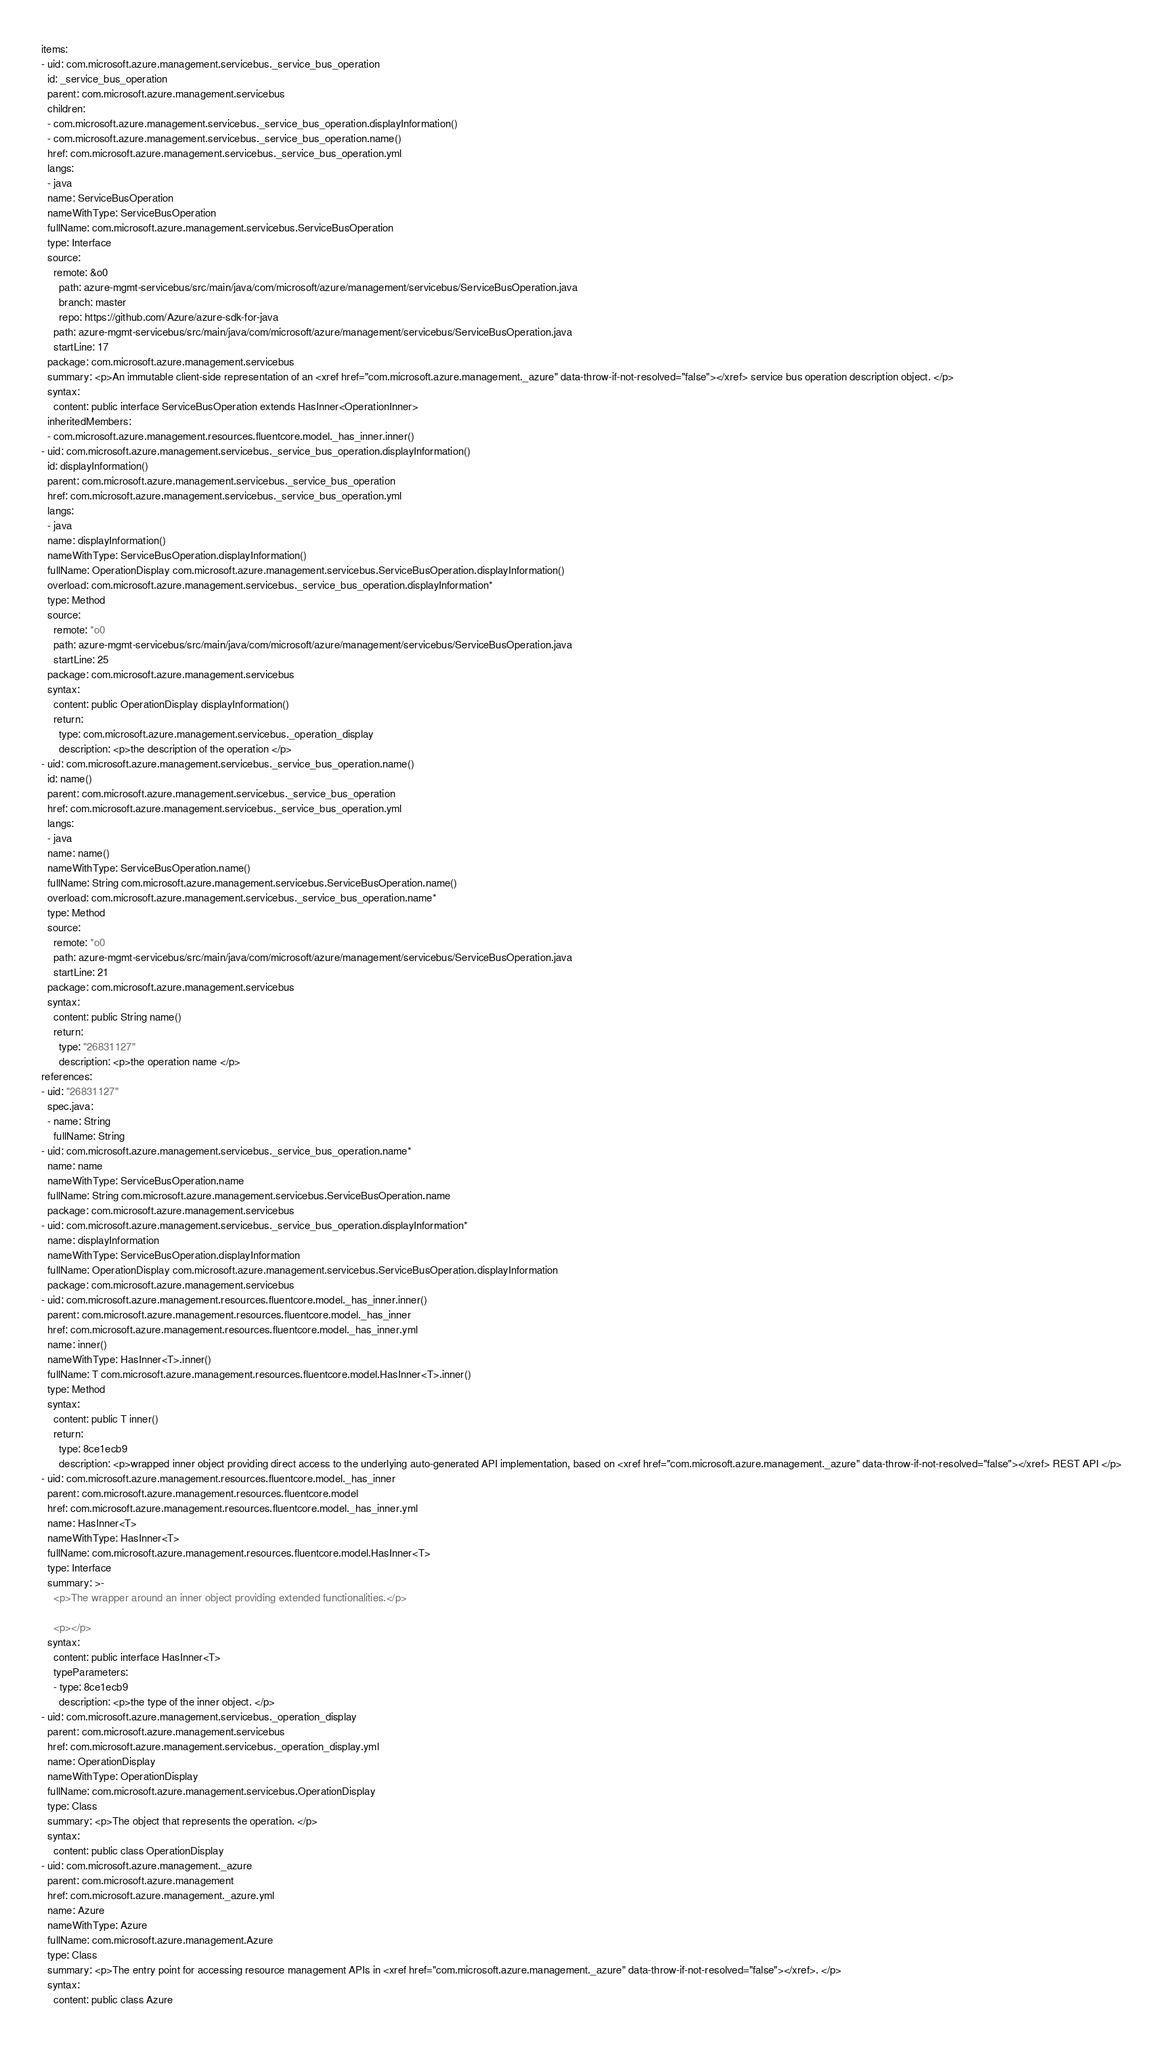Convert code to text. <code><loc_0><loc_0><loc_500><loc_500><_YAML_>items:
- uid: com.microsoft.azure.management.servicebus._service_bus_operation
  id: _service_bus_operation
  parent: com.microsoft.azure.management.servicebus
  children:
  - com.microsoft.azure.management.servicebus._service_bus_operation.displayInformation()
  - com.microsoft.azure.management.servicebus._service_bus_operation.name()
  href: com.microsoft.azure.management.servicebus._service_bus_operation.yml
  langs:
  - java
  name: ServiceBusOperation
  nameWithType: ServiceBusOperation
  fullName: com.microsoft.azure.management.servicebus.ServiceBusOperation
  type: Interface
  source:
    remote: &o0
      path: azure-mgmt-servicebus/src/main/java/com/microsoft/azure/management/servicebus/ServiceBusOperation.java
      branch: master
      repo: https://github.com/Azure/azure-sdk-for-java
    path: azure-mgmt-servicebus/src/main/java/com/microsoft/azure/management/servicebus/ServiceBusOperation.java
    startLine: 17
  package: com.microsoft.azure.management.servicebus
  summary: <p>An immutable client-side representation of an <xref href="com.microsoft.azure.management._azure" data-throw-if-not-resolved="false"></xref> service bus operation description object. </p>
  syntax:
    content: public interface ServiceBusOperation extends HasInner<OperationInner>
  inheritedMembers:
  - com.microsoft.azure.management.resources.fluentcore.model._has_inner.inner()
- uid: com.microsoft.azure.management.servicebus._service_bus_operation.displayInformation()
  id: displayInformation()
  parent: com.microsoft.azure.management.servicebus._service_bus_operation
  href: com.microsoft.azure.management.servicebus._service_bus_operation.yml
  langs:
  - java
  name: displayInformation()
  nameWithType: ServiceBusOperation.displayInformation()
  fullName: OperationDisplay com.microsoft.azure.management.servicebus.ServiceBusOperation.displayInformation()
  overload: com.microsoft.azure.management.servicebus._service_bus_operation.displayInformation*
  type: Method
  source:
    remote: *o0
    path: azure-mgmt-servicebus/src/main/java/com/microsoft/azure/management/servicebus/ServiceBusOperation.java
    startLine: 25
  package: com.microsoft.azure.management.servicebus
  syntax:
    content: public OperationDisplay displayInformation()
    return:
      type: com.microsoft.azure.management.servicebus._operation_display
      description: <p>the description of the operation </p>
- uid: com.microsoft.azure.management.servicebus._service_bus_operation.name()
  id: name()
  parent: com.microsoft.azure.management.servicebus._service_bus_operation
  href: com.microsoft.azure.management.servicebus._service_bus_operation.yml
  langs:
  - java
  name: name()
  nameWithType: ServiceBusOperation.name()
  fullName: String com.microsoft.azure.management.servicebus.ServiceBusOperation.name()
  overload: com.microsoft.azure.management.servicebus._service_bus_operation.name*
  type: Method
  source:
    remote: *o0
    path: azure-mgmt-servicebus/src/main/java/com/microsoft/azure/management/servicebus/ServiceBusOperation.java
    startLine: 21
  package: com.microsoft.azure.management.servicebus
  syntax:
    content: public String name()
    return:
      type: "26831127"
      description: <p>the operation name </p>
references:
- uid: "26831127"
  spec.java:
  - name: String
    fullName: String
- uid: com.microsoft.azure.management.servicebus._service_bus_operation.name*
  name: name
  nameWithType: ServiceBusOperation.name
  fullName: String com.microsoft.azure.management.servicebus.ServiceBusOperation.name
  package: com.microsoft.azure.management.servicebus
- uid: com.microsoft.azure.management.servicebus._service_bus_operation.displayInformation*
  name: displayInformation
  nameWithType: ServiceBusOperation.displayInformation
  fullName: OperationDisplay com.microsoft.azure.management.servicebus.ServiceBusOperation.displayInformation
  package: com.microsoft.azure.management.servicebus
- uid: com.microsoft.azure.management.resources.fluentcore.model._has_inner.inner()
  parent: com.microsoft.azure.management.resources.fluentcore.model._has_inner
  href: com.microsoft.azure.management.resources.fluentcore.model._has_inner.yml
  name: inner()
  nameWithType: HasInner<T>.inner()
  fullName: T com.microsoft.azure.management.resources.fluentcore.model.HasInner<T>.inner()
  type: Method
  syntax:
    content: public T inner()
    return:
      type: 8ce1ecb9
      description: <p>wrapped inner object providing direct access to the underlying auto-generated API implementation, based on <xref href="com.microsoft.azure.management._azure" data-throw-if-not-resolved="false"></xref> REST API </p>
- uid: com.microsoft.azure.management.resources.fluentcore.model._has_inner
  parent: com.microsoft.azure.management.resources.fluentcore.model
  href: com.microsoft.azure.management.resources.fluentcore.model._has_inner.yml
  name: HasInner<T>
  nameWithType: HasInner<T>
  fullName: com.microsoft.azure.management.resources.fluentcore.model.HasInner<T>
  type: Interface
  summary: >-
    <p>The wrapper around an inner object providing extended functionalities.</p>

    <p></p>
  syntax:
    content: public interface HasInner<T>
    typeParameters:
    - type: 8ce1ecb9
      description: <p>the type of the inner object. </p>
- uid: com.microsoft.azure.management.servicebus._operation_display
  parent: com.microsoft.azure.management.servicebus
  href: com.microsoft.azure.management.servicebus._operation_display.yml
  name: OperationDisplay
  nameWithType: OperationDisplay
  fullName: com.microsoft.azure.management.servicebus.OperationDisplay
  type: Class
  summary: <p>The object that represents the operation. </p>
  syntax:
    content: public class OperationDisplay
- uid: com.microsoft.azure.management._azure
  parent: com.microsoft.azure.management
  href: com.microsoft.azure.management._azure.yml
  name: Azure
  nameWithType: Azure
  fullName: com.microsoft.azure.management.Azure
  type: Class
  summary: <p>The entry point for accessing resource management APIs in <xref href="com.microsoft.azure.management._azure" data-throw-if-not-resolved="false"></xref>. </p>
  syntax:
    content: public class Azure
</code> 